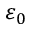<formula> <loc_0><loc_0><loc_500><loc_500>\varepsilon _ { 0 }</formula> 